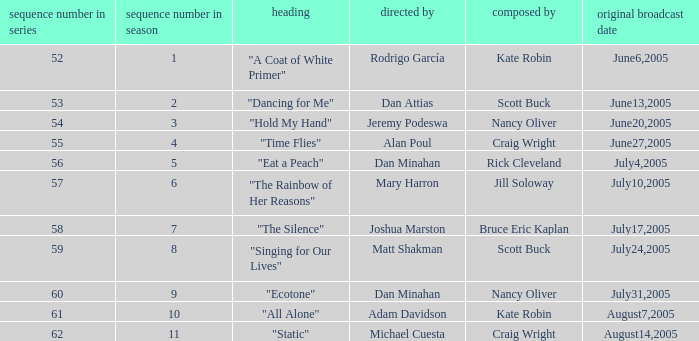What s the episode number in the season that was written by Nancy Oliver? 9.0. 